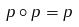Convert formula to latex. <formula><loc_0><loc_0><loc_500><loc_500>p \circ p = p</formula> 